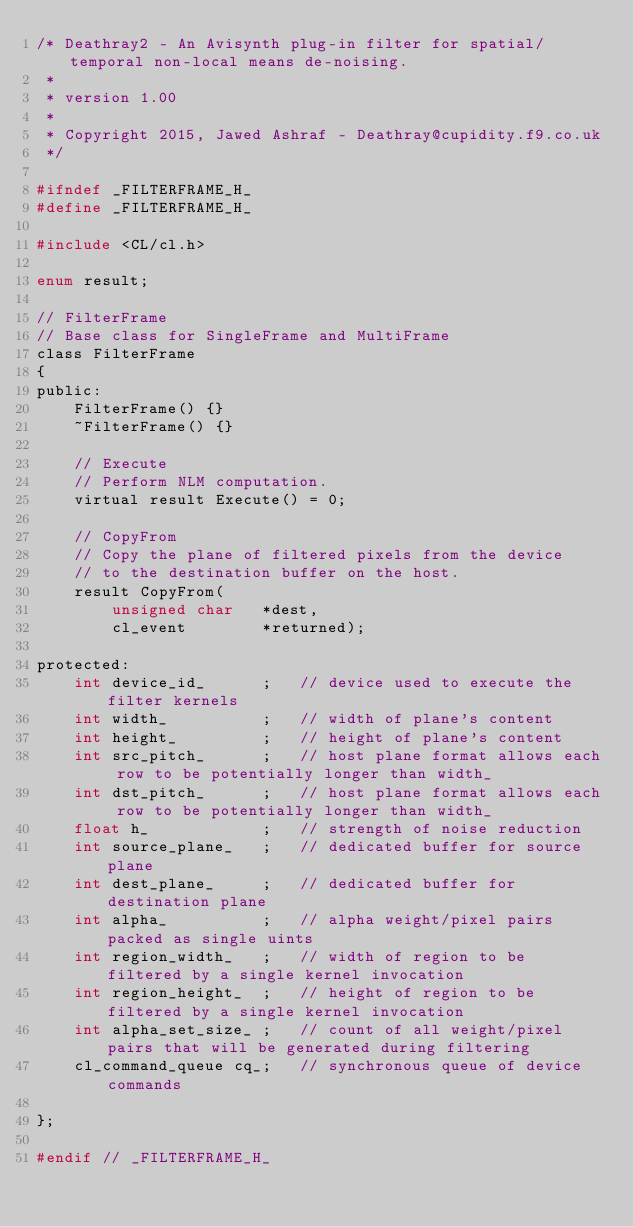Convert code to text. <code><loc_0><loc_0><loc_500><loc_500><_C_>/* Deathray2 - An Avisynth plug-in filter for spatial/temporal non-local means de-noising.
 *
 * version 1.00
 *
 * Copyright 2015, Jawed Ashraf - Deathray@cupidity.f9.co.uk
 */

#ifndef _FILTERFRAME_H_
#define _FILTERFRAME_H_

#include <CL/cl.h>

enum result;

// FilterFrame
// Base class for SingleFrame and MultiFrame
class FilterFrame
{
public:
    FilterFrame() {}
    ~FilterFrame() {}
    
    // Execute
    // Perform NLM computation.
    virtual result Execute() = 0;

    // CopyFrom
    // Copy the plane of filtered pixels from the device
    // to the destination buffer on the host.
    result CopyFrom(
        unsigned char   *dest,
        cl_event        *returned);

protected:
    int device_id_      ;   // device used to execute the filter kernels
    int width_          ;   // width of plane's content
    int height_         ;   // height of plane's content
    int src_pitch_      ;   // host plane format allows each row to be potentially longer than width_
    int dst_pitch_      ;   // host plane format allows each row to be potentially longer than width_
    float h_            ;   // strength of noise reduction
    int source_plane_   ;   // dedicated buffer for source plane
    int dest_plane_     ;   // dedicated buffer for destination plane
    int alpha_          ;   // alpha weight/pixel pairs packed as single uints
    int region_width_   ;   // width of region to be filtered by a single kernel invocation
    int region_height_  ;   // height of region to be filtered by a single kernel invocation
    int alpha_set_size_ ;   // count of all weight/pixel pairs that will be generated during filtering
    cl_command_queue cq_;   // synchronous queue of device commands

};

#endif // _FILTERFRAME_H_

</code> 